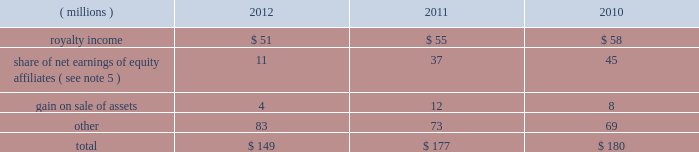68 2012 ppg annual report and form 10-k december 31 , 2012 , 2011 and 2010 was $ ( 30 ) million , $ 98 million and $ 65 million , respectively .
The cumulative tax benefit related to the adjustment for pension and other postretirement benefits at december 31 , 2012 and 2011 was approximately $ 960 million and $ 990 million , respectively .
There was no tax ( cost ) benefit related to the change in the unrealized gain ( loss ) on marketable securities for the year ended december 31 , 2012 .
The tax ( cost ) benefit related to the change in the unrealized gain ( loss ) on marketable securities for the years ended december 31 , 2011 and 2010 was $ ( 0.2 ) million and $ 0.6 million , respectively .
The tax benefit related to the change in the unrealized gain ( loss ) on derivatives for the years ended december 31 , 2012 , 2011 and 2010 was $ 4 million , $ 19 million and $ 1 million , respectively .
18 .
Employee savings plan ppg 2019s employee savings plan ( 201csavings plan 201d ) covers substantially all u.s .
Employees .
The company makes matching contributions to the savings plan , at management's discretion , based upon participants 2019 savings , subject to certain limitations .
For most participants not covered by a collective bargaining agreement , company-matching contributions are established each year at the discretion of the company and are applied to participant savings up to a maximum of 6% ( 6 % ) of eligible participant compensation .
For those participants whose employment is covered by a collective bargaining agreement , the level of company-matching contribution , if any , is determined by the relevant collective bargaining agreement .
The company-matching contribution was suspended from march 2009 through june 2010 as a cost savings measure in recognition of the adverse impact of the global recession .
Effective july 1 , 2010 , the company match was reinstated at 50% ( 50 % ) on the first 6% ( 6 % ) of compensation contributed for most employees eligible for the company-matching contribution feature .
This included the union represented employees in accordance with their collective bargaining agreements .
On january 1 , 2011 , the company match was increased to 75% ( 75 % ) on the first 6% ( 6 % ) of compensation contributed by these eligible employees and this level was maintained throughout 2012 .
Compensation expense and cash contributions related to the company match of participant contributions to the savings plan for 2012 , 2011 and 2010 totaled $ 28 million , $ 26 million and $ 9 million , respectively .
A portion of the savings plan qualifies under the internal revenue code as an employee stock ownership plan .
As a result , the dividends on ppg shares held by that portion of the savings plan totaling $ 18 million , $ 20 million and $ 24 million for 2012 , 2011 and 2010 , respectively , were tax deductible to the company for u.s .
Federal tax purposes .
19 .
Other earnings .
20 .
Stock-based compensation the company 2019s stock-based compensation includes stock options , restricted stock units ( 201crsus 201d ) and grants of contingent shares that are earned based on achieving targeted levels of total shareholder return .
All current grants of stock options , rsus and contingent shares are made under the ppg industries , inc .
Amended and restated omnibus incentive plan ( 201cppg amended omnibus plan 201d ) , which was amended and restated effective april 21 , 2011 .
Shares available for future grants under the ppg amended omnibus plan were 8.5 million as of december 31 , 2012 .
Total stock-based compensation cost was $ 73 million , $ 36 million and $ 52 million in 2012 , 2011 and 2010 , respectively .
Stock-based compensation expense increased year over year due to the increase in the expected payout percentage of the 2010 performance-based rsu grants and ppg's total shareholder return performance in 2012 in comparison with the standard & poors ( s&p ) 500 index , which has increased the expense related to outstanding grants of contingent shares .
The total income tax benefit recognized in the accompanying consolidated statement of income related to the stock-based compensation was $ 25 million , $ 13 million and $ 18 million in 2012 , 2011 and 2010 , respectively .
Stock options ppg has outstanding stock option awards that have been granted under two stock option plans : the ppg industries , inc .
Stock plan ( 201cppg stock plan 201d ) and the ppg amended omnibus plan .
Under the ppg amended omnibus plan and the ppg stock plan , certain employees of the company have been granted options to purchase shares of common stock at prices equal to the fair market value of the shares on the date the options were granted .
The options are generally exercisable beginning from six to 48 months after being granted and have a maximum term of 10 years .
Upon exercise of a stock option , shares of company stock are issued from treasury stock .
The ppg stock plan includes a restored option provision for options originally granted prior to january 1 , 2003 that allows an optionee to exercise options and satisfy the option cost by certifying ownership of mature shares of ppg common stock with a market value equal to the option cost .
The fair value of stock options issued to employees is measured on the date of grant and is recognized as expense over the requisite service period .
Ppg estimates the fair value of stock options using the black-scholes option pricing model .
The risk- free interest rate is determined by using the u.s .
Treasury yield table of contents .
What was the change in millions of total stock-based compensation cost from 2011 to 2012? 
Computations: (73 - 36)
Answer: 37.0. 